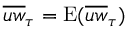<formula> <loc_0><loc_0><loc_500><loc_500>\overline { u w } _ { \tau } = E ( \overline { u w } _ { \tau } )</formula> 